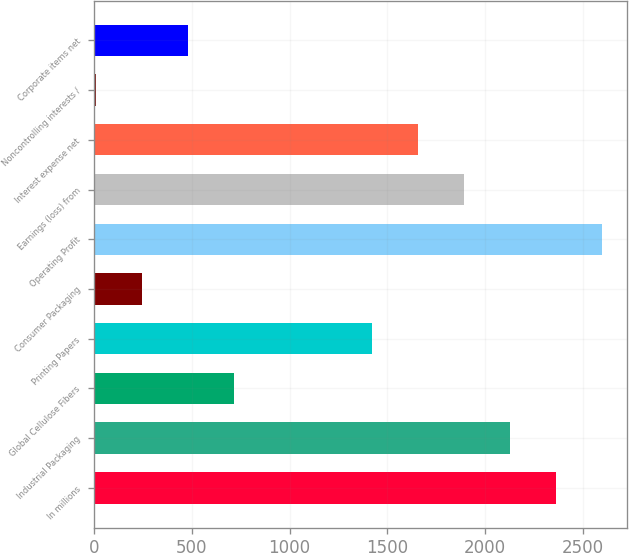Convert chart to OTSL. <chart><loc_0><loc_0><loc_500><loc_500><bar_chart><fcel>In millions<fcel>Industrial Packaging<fcel>Global Cellulose Fibers<fcel>Printing Papers<fcel>Consumer Packaging<fcel>Operating Profit<fcel>Earnings (loss) from<fcel>Interest expense net<fcel>Noncontrolling interests /<fcel>Corporate items net<nl><fcel>2361<fcel>2125.7<fcel>713.9<fcel>1419.8<fcel>243.3<fcel>2596.3<fcel>1890.4<fcel>1655.1<fcel>8<fcel>478.6<nl></chart> 